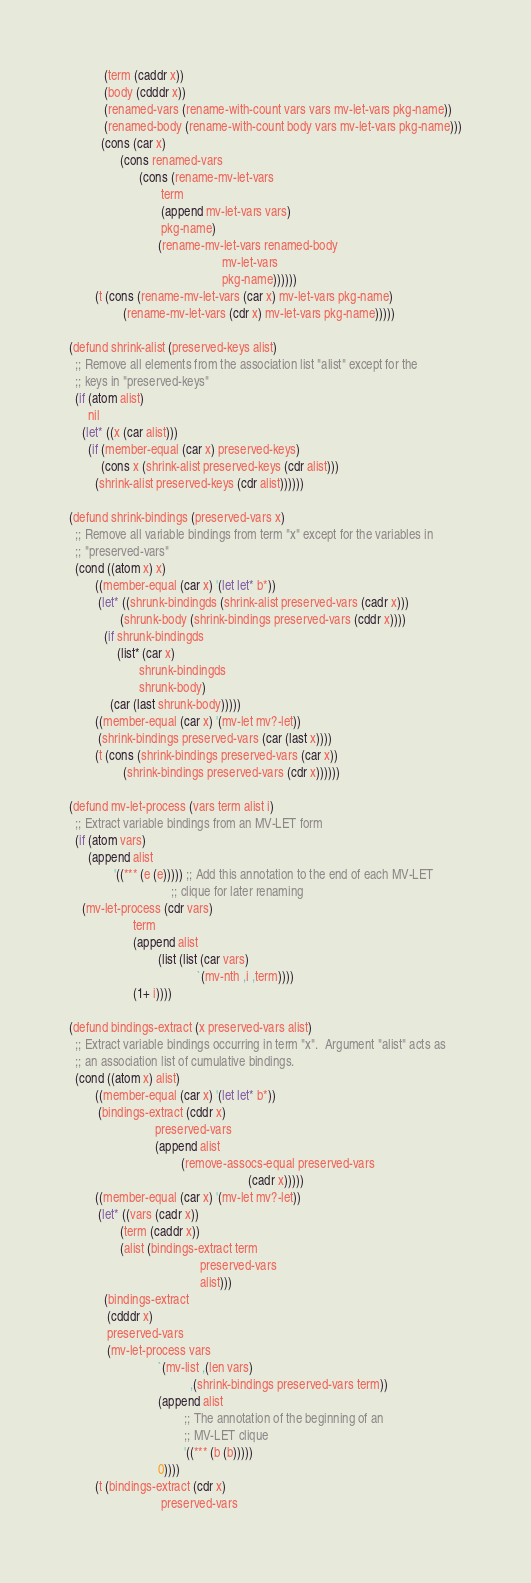Convert code to text. <code><loc_0><loc_0><loc_500><loc_500><_Lisp_>           (term (caddr x))
           (body (cdddr x))
           (renamed-vars (rename-with-count vars vars mv-let-vars pkg-name))
           (renamed-body (rename-with-count body vars mv-let-vars pkg-name)))
          (cons (car x)
                (cons renamed-vars
                      (cons (rename-mv-let-vars
                             term
                             (append mv-let-vars vars)
                             pkg-name)
                            (rename-mv-let-vars renamed-body
                                                mv-let-vars
                                                pkg-name))))))
        (t (cons (rename-mv-let-vars (car x) mv-let-vars pkg-name)
                 (rename-mv-let-vars (cdr x) mv-let-vars pkg-name)))))

(defund shrink-alist (preserved-keys alist)
  ;; Remove all elements from the association list "alist" except for the
  ;; keys in "preserved-keys"
  (if (atom alist)
      nil
    (let* ((x (car alist)))
      (if (member-equal (car x) preserved-keys)
          (cons x (shrink-alist preserved-keys (cdr alist)))
        (shrink-alist preserved-keys (cdr alist))))))

(defund shrink-bindings (preserved-vars x)
  ;; Remove all variable bindings from term "x" except for the variables in
  ;; "preserved-vars"
  (cond ((atom x) x)
        ((member-equal (car x) '(let let* b*))
         (let* ((shrunk-bindingds (shrink-alist preserved-vars (cadr x)))
                (shrunk-body (shrink-bindings preserved-vars (cddr x))))
           (if shrunk-bindingds
               (list* (car x)
                      shrunk-bindingds
                      shrunk-body)
             (car (last shrunk-body)))))
        ((member-equal (car x) '(mv-let mv?-let))
         (shrink-bindings preserved-vars (car (last x))))
        (t (cons (shrink-bindings preserved-vars (car x))
                 (shrink-bindings preserved-vars (cdr x))))))

(defund mv-let-process (vars term alist i)
  ;; Extract variable bindings from an MV-LET form
  (if (atom vars)
      (append alist
              '((*** (e (e))))) ;; Add this annotation to the end of each MV-LET
                                ;; clique for later renaming
    (mv-let-process (cdr vars)
                    term
                    (append alist
                            (list (list (car vars)
                                        `(mv-nth ,i ,term))))
                    (1+ i))))

(defund bindings-extract (x preserved-vars alist)
  ;; Extract variable bindings occurring in term "x".  Argument "alist" acts as
  ;; an association list of cumulative bindings.
  (cond ((atom x) alist)
        ((member-equal (car x) '(let let* b*))
         (bindings-extract (cddr x)
                           preserved-vars
                           (append alist
                                   (remove-assocs-equal preserved-vars
                                                        (cadr x)))))
        ((member-equal (car x) '(mv-let mv?-let))
         (let* ((vars (cadr x))
                (term (caddr x))
                (alist (bindings-extract term
                                         preserved-vars
                                         alist)))
           (bindings-extract
            (cdddr x)
            preserved-vars
            (mv-let-process vars
                            `(mv-list ,(len vars)
                                      ,(shrink-bindings preserved-vars term))
                            (append alist
                                    ;; The annotation of the beginning of an
                                    ;; MV-LET clique
                                    '((*** (b (b)))))
                            0))))
        (t (bindings-extract (cdr x)
                             preserved-vars</code> 